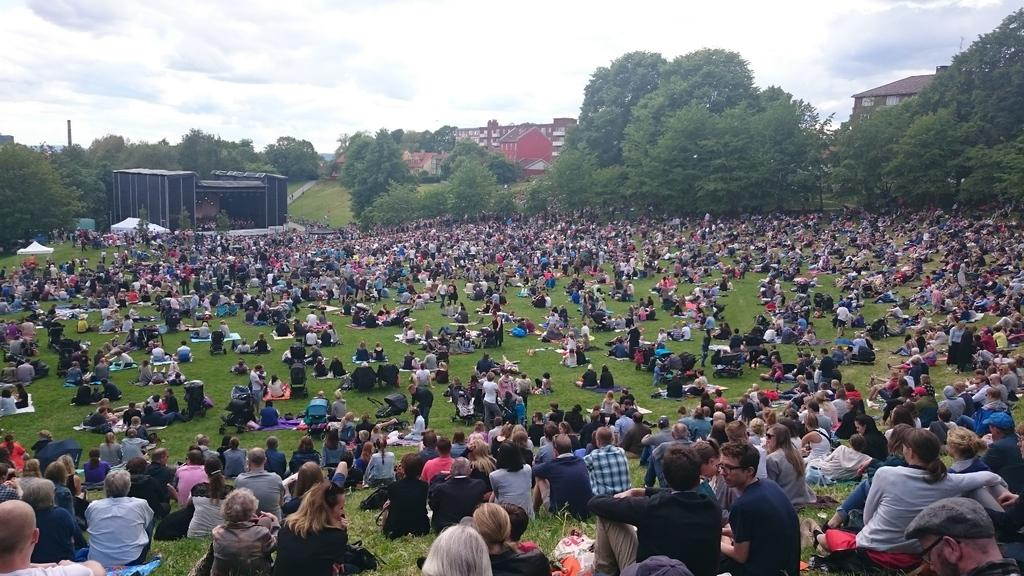What are the people in the image doing? The people in the image are sitting on the grass. What is located in front of the people? There is a stage in front of the people. What type of structures can be seen in the image? There are buildings visible in the image. What type of vegetation is present in the image? There are trees in the image. What type of van is parked near the stage in the image? There is no van present in the image; it only features people sitting on the grass, a stage, buildings, and trees. 